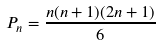<formula> <loc_0><loc_0><loc_500><loc_500>P _ { n } = { \frac { n ( n + 1 ) ( 2 n + 1 ) } { 6 } }</formula> 